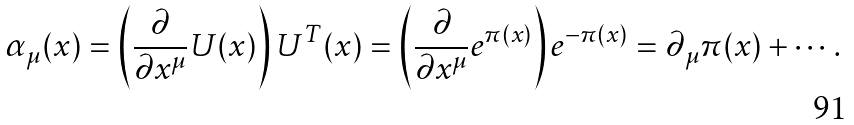Convert formula to latex. <formula><loc_0><loc_0><loc_500><loc_500>\alpha _ { \mu } ( x ) & = \left ( \frac { \partial } { \partial x ^ { \mu } } U ( x ) \right ) U ^ { T } ( x ) = \left ( \frac { \partial } { \partial x ^ { \mu } } e ^ { \pi ( x ) } \right ) e ^ { - \pi ( x ) } = \partial _ { \mu } \pi ( x ) + \cdots .</formula> 